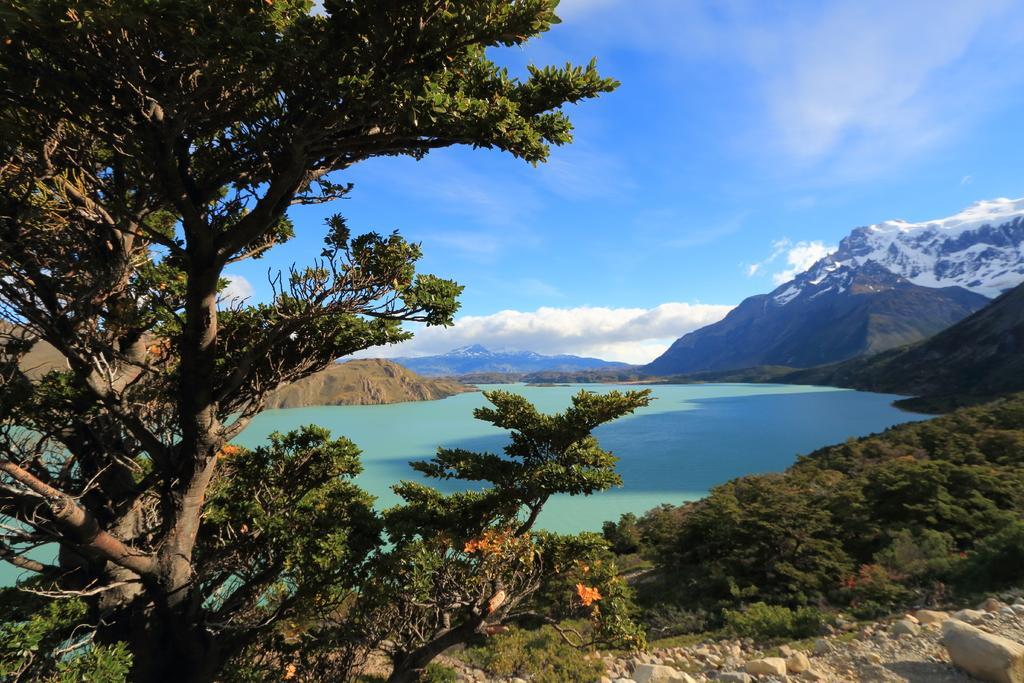In one or two sentences, can you explain what this image depicts? In this image I can see trees , bushes and the lake, the sky and the hill 